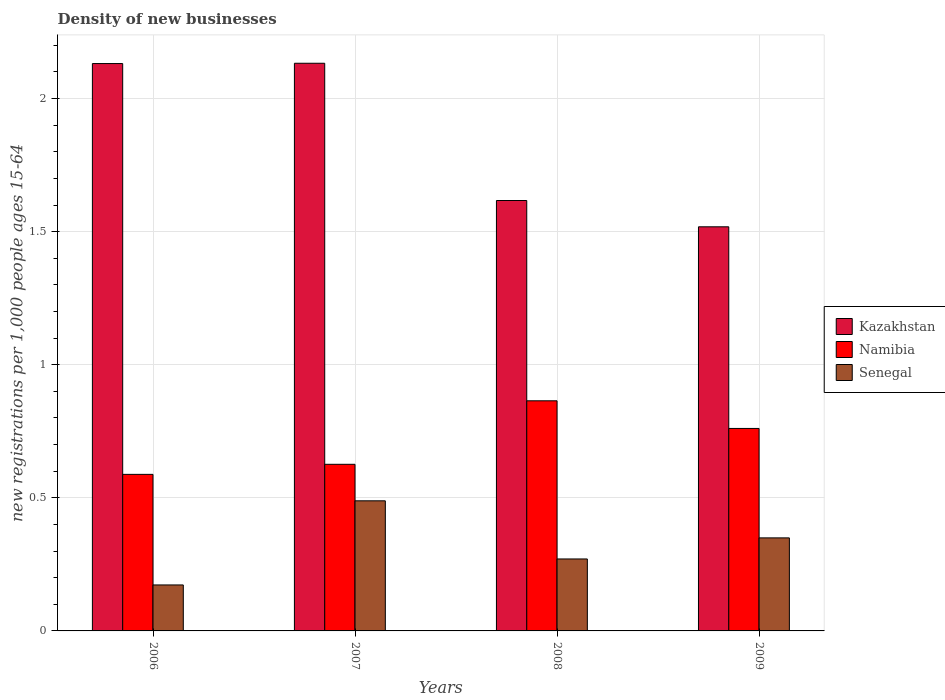How many different coloured bars are there?
Your answer should be very brief. 3. Are the number of bars per tick equal to the number of legend labels?
Your answer should be very brief. Yes. Are the number of bars on each tick of the X-axis equal?
Provide a succinct answer. Yes. How many bars are there on the 3rd tick from the left?
Keep it short and to the point. 3. How many bars are there on the 2nd tick from the right?
Make the answer very short. 3. What is the number of new registrations in Kazakhstan in 2007?
Offer a very short reply. 2.13. Across all years, what is the maximum number of new registrations in Senegal?
Keep it short and to the point. 0.49. Across all years, what is the minimum number of new registrations in Kazakhstan?
Offer a terse response. 1.52. What is the total number of new registrations in Kazakhstan in the graph?
Your response must be concise. 7.4. What is the difference between the number of new registrations in Kazakhstan in 2007 and that in 2008?
Your answer should be very brief. 0.52. What is the difference between the number of new registrations in Kazakhstan in 2007 and the number of new registrations in Senegal in 2009?
Your response must be concise. 1.78. What is the average number of new registrations in Namibia per year?
Provide a succinct answer. 0.71. In the year 2008, what is the difference between the number of new registrations in Namibia and number of new registrations in Senegal?
Your answer should be very brief. 0.59. What is the ratio of the number of new registrations in Senegal in 2007 to that in 2009?
Ensure brevity in your answer.  1.4. Is the difference between the number of new registrations in Namibia in 2008 and 2009 greater than the difference between the number of new registrations in Senegal in 2008 and 2009?
Provide a succinct answer. Yes. What is the difference between the highest and the second highest number of new registrations in Namibia?
Offer a very short reply. 0.1. What is the difference between the highest and the lowest number of new registrations in Senegal?
Provide a short and direct response. 0.32. In how many years, is the number of new registrations in Senegal greater than the average number of new registrations in Senegal taken over all years?
Your answer should be very brief. 2. Is the sum of the number of new registrations in Kazakhstan in 2008 and 2009 greater than the maximum number of new registrations in Namibia across all years?
Ensure brevity in your answer.  Yes. What does the 1st bar from the left in 2009 represents?
Ensure brevity in your answer.  Kazakhstan. What does the 3rd bar from the right in 2007 represents?
Make the answer very short. Kazakhstan. How many bars are there?
Ensure brevity in your answer.  12. Are all the bars in the graph horizontal?
Your answer should be compact. No. What is the difference between two consecutive major ticks on the Y-axis?
Make the answer very short. 0.5. Are the values on the major ticks of Y-axis written in scientific E-notation?
Ensure brevity in your answer.  No. Does the graph contain any zero values?
Ensure brevity in your answer.  No. Where does the legend appear in the graph?
Keep it short and to the point. Center right. How many legend labels are there?
Make the answer very short. 3. What is the title of the graph?
Provide a succinct answer. Density of new businesses. Does "Bosnia and Herzegovina" appear as one of the legend labels in the graph?
Make the answer very short. No. What is the label or title of the X-axis?
Keep it short and to the point. Years. What is the label or title of the Y-axis?
Keep it short and to the point. New registrations per 1,0 people ages 15-64. What is the new registrations per 1,000 people ages 15-64 in Kazakhstan in 2006?
Provide a succinct answer. 2.13. What is the new registrations per 1,000 people ages 15-64 of Namibia in 2006?
Offer a very short reply. 0.59. What is the new registrations per 1,000 people ages 15-64 of Senegal in 2006?
Make the answer very short. 0.17. What is the new registrations per 1,000 people ages 15-64 of Kazakhstan in 2007?
Keep it short and to the point. 2.13. What is the new registrations per 1,000 people ages 15-64 of Namibia in 2007?
Keep it short and to the point. 0.63. What is the new registrations per 1,000 people ages 15-64 of Senegal in 2007?
Keep it short and to the point. 0.49. What is the new registrations per 1,000 people ages 15-64 of Kazakhstan in 2008?
Provide a short and direct response. 1.62. What is the new registrations per 1,000 people ages 15-64 of Namibia in 2008?
Give a very brief answer. 0.86. What is the new registrations per 1,000 people ages 15-64 in Senegal in 2008?
Ensure brevity in your answer.  0.27. What is the new registrations per 1,000 people ages 15-64 in Kazakhstan in 2009?
Your answer should be very brief. 1.52. What is the new registrations per 1,000 people ages 15-64 of Namibia in 2009?
Your answer should be compact. 0.76. What is the new registrations per 1,000 people ages 15-64 of Senegal in 2009?
Ensure brevity in your answer.  0.35. Across all years, what is the maximum new registrations per 1,000 people ages 15-64 in Kazakhstan?
Offer a very short reply. 2.13. Across all years, what is the maximum new registrations per 1,000 people ages 15-64 in Namibia?
Give a very brief answer. 0.86. Across all years, what is the maximum new registrations per 1,000 people ages 15-64 of Senegal?
Your answer should be very brief. 0.49. Across all years, what is the minimum new registrations per 1,000 people ages 15-64 of Kazakhstan?
Your response must be concise. 1.52. Across all years, what is the minimum new registrations per 1,000 people ages 15-64 in Namibia?
Your answer should be compact. 0.59. Across all years, what is the minimum new registrations per 1,000 people ages 15-64 of Senegal?
Make the answer very short. 0.17. What is the total new registrations per 1,000 people ages 15-64 of Kazakhstan in the graph?
Your answer should be very brief. 7.4. What is the total new registrations per 1,000 people ages 15-64 of Namibia in the graph?
Give a very brief answer. 2.84. What is the total new registrations per 1,000 people ages 15-64 of Senegal in the graph?
Make the answer very short. 1.28. What is the difference between the new registrations per 1,000 people ages 15-64 in Kazakhstan in 2006 and that in 2007?
Ensure brevity in your answer.  -0. What is the difference between the new registrations per 1,000 people ages 15-64 in Namibia in 2006 and that in 2007?
Offer a terse response. -0.04. What is the difference between the new registrations per 1,000 people ages 15-64 of Senegal in 2006 and that in 2007?
Give a very brief answer. -0.32. What is the difference between the new registrations per 1,000 people ages 15-64 in Kazakhstan in 2006 and that in 2008?
Provide a succinct answer. 0.51. What is the difference between the new registrations per 1,000 people ages 15-64 of Namibia in 2006 and that in 2008?
Your response must be concise. -0.28. What is the difference between the new registrations per 1,000 people ages 15-64 of Senegal in 2006 and that in 2008?
Keep it short and to the point. -0.1. What is the difference between the new registrations per 1,000 people ages 15-64 in Kazakhstan in 2006 and that in 2009?
Ensure brevity in your answer.  0.61. What is the difference between the new registrations per 1,000 people ages 15-64 of Namibia in 2006 and that in 2009?
Your answer should be compact. -0.17. What is the difference between the new registrations per 1,000 people ages 15-64 of Senegal in 2006 and that in 2009?
Keep it short and to the point. -0.18. What is the difference between the new registrations per 1,000 people ages 15-64 of Kazakhstan in 2007 and that in 2008?
Ensure brevity in your answer.  0.52. What is the difference between the new registrations per 1,000 people ages 15-64 of Namibia in 2007 and that in 2008?
Offer a terse response. -0.24. What is the difference between the new registrations per 1,000 people ages 15-64 in Senegal in 2007 and that in 2008?
Offer a very short reply. 0.22. What is the difference between the new registrations per 1,000 people ages 15-64 in Kazakhstan in 2007 and that in 2009?
Your answer should be compact. 0.61. What is the difference between the new registrations per 1,000 people ages 15-64 in Namibia in 2007 and that in 2009?
Give a very brief answer. -0.13. What is the difference between the new registrations per 1,000 people ages 15-64 in Senegal in 2007 and that in 2009?
Give a very brief answer. 0.14. What is the difference between the new registrations per 1,000 people ages 15-64 in Kazakhstan in 2008 and that in 2009?
Make the answer very short. 0.1. What is the difference between the new registrations per 1,000 people ages 15-64 in Namibia in 2008 and that in 2009?
Provide a succinct answer. 0.1. What is the difference between the new registrations per 1,000 people ages 15-64 in Senegal in 2008 and that in 2009?
Your answer should be very brief. -0.08. What is the difference between the new registrations per 1,000 people ages 15-64 in Kazakhstan in 2006 and the new registrations per 1,000 people ages 15-64 in Namibia in 2007?
Provide a succinct answer. 1.51. What is the difference between the new registrations per 1,000 people ages 15-64 in Kazakhstan in 2006 and the new registrations per 1,000 people ages 15-64 in Senegal in 2007?
Provide a succinct answer. 1.64. What is the difference between the new registrations per 1,000 people ages 15-64 in Namibia in 2006 and the new registrations per 1,000 people ages 15-64 in Senegal in 2007?
Give a very brief answer. 0.1. What is the difference between the new registrations per 1,000 people ages 15-64 in Kazakhstan in 2006 and the new registrations per 1,000 people ages 15-64 in Namibia in 2008?
Keep it short and to the point. 1.27. What is the difference between the new registrations per 1,000 people ages 15-64 in Kazakhstan in 2006 and the new registrations per 1,000 people ages 15-64 in Senegal in 2008?
Your answer should be very brief. 1.86. What is the difference between the new registrations per 1,000 people ages 15-64 of Namibia in 2006 and the new registrations per 1,000 people ages 15-64 of Senegal in 2008?
Give a very brief answer. 0.32. What is the difference between the new registrations per 1,000 people ages 15-64 in Kazakhstan in 2006 and the new registrations per 1,000 people ages 15-64 in Namibia in 2009?
Your answer should be compact. 1.37. What is the difference between the new registrations per 1,000 people ages 15-64 of Kazakhstan in 2006 and the new registrations per 1,000 people ages 15-64 of Senegal in 2009?
Provide a succinct answer. 1.78. What is the difference between the new registrations per 1,000 people ages 15-64 in Namibia in 2006 and the new registrations per 1,000 people ages 15-64 in Senegal in 2009?
Your answer should be very brief. 0.24. What is the difference between the new registrations per 1,000 people ages 15-64 of Kazakhstan in 2007 and the new registrations per 1,000 people ages 15-64 of Namibia in 2008?
Provide a succinct answer. 1.27. What is the difference between the new registrations per 1,000 people ages 15-64 of Kazakhstan in 2007 and the new registrations per 1,000 people ages 15-64 of Senegal in 2008?
Offer a terse response. 1.86. What is the difference between the new registrations per 1,000 people ages 15-64 in Namibia in 2007 and the new registrations per 1,000 people ages 15-64 in Senegal in 2008?
Provide a succinct answer. 0.36. What is the difference between the new registrations per 1,000 people ages 15-64 of Kazakhstan in 2007 and the new registrations per 1,000 people ages 15-64 of Namibia in 2009?
Provide a succinct answer. 1.37. What is the difference between the new registrations per 1,000 people ages 15-64 of Kazakhstan in 2007 and the new registrations per 1,000 people ages 15-64 of Senegal in 2009?
Give a very brief answer. 1.78. What is the difference between the new registrations per 1,000 people ages 15-64 of Namibia in 2007 and the new registrations per 1,000 people ages 15-64 of Senegal in 2009?
Your answer should be very brief. 0.28. What is the difference between the new registrations per 1,000 people ages 15-64 in Kazakhstan in 2008 and the new registrations per 1,000 people ages 15-64 in Namibia in 2009?
Keep it short and to the point. 0.86. What is the difference between the new registrations per 1,000 people ages 15-64 in Kazakhstan in 2008 and the new registrations per 1,000 people ages 15-64 in Senegal in 2009?
Your answer should be compact. 1.27. What is the difference between the new registrations per 1,000 people ages 15-64 of Namibia in 2008 and the new registrations per 1,000 people ages 15-64 of Senegal in 2009?
Make the answer very short. 0.52. What is the average new registrations per 1,000 people ages 15-64 in Kazakhstan per year?
Ensure brevity in your answer.  1.85. What is the average new registrations per 1,000 people ages 15-64 in Namibia per year?
Your response must be concise. 0.71. What is the average new registrations per 1,000 people ages 15-64 of Senegal per year?
Make the answer very short. 0.32. In the year 2006, what is the difference between the new registrations per 1,000 people ages 15-64 of Kazakhstan and new registrations per 1,000 people ages 15-64 of Namibia?
Keep it short and to the point. 1.54. In the year 2006, what is the difference between the new registrations per 1,000 people ages 15-64 of Kazakhstan and new registrations per 1,000 people ages 15-64 of Senegal?
Ensure brevity in your answer.  1.96. In the year 2006, what is the difference between the new registrations per 1,000 people ages 15-64 of Namibia and new registrations per 1,000 people ages 15-64 of Senegal?
Ensure brevity in your answer.  0.42. In the year 2007, what is the difference between the new registrations per 1,000 people ages 15-64 of Kazakhstan and new registrations per 1,000 people ages 15-64 of Namibia?
Offer a terse response. 1.51. In the year 2007, what is the difference between the new registrations per 1,000 people ages 15-64 in Kazakhstan and new registrations per 1,000 people ages 15-64 in Senegal?
Offer a very short reply. 1.64. In the year 2007, what is the difference between the new registrations per 1,000 people ages 15-64 of Namibia and new registrations per 1,000 people ages 15-64 of Senegal?
Your response must be concise. 0.14. In the year 2008, what is the difference between the new registrations per 1,000 people ages 15-64 in Kazakhstan and new registrations per 1,000 people ages 15-64 in Namibia?
Provide a succinct answer. 0.75. In the year 2008, what is the difference between the new registrations per 1,000 people ages 15-64 in Kazakhstan and new registrations per 1,000 people ages 15-64 in Senegal?
Provide a succinct answer. 1.35. In the year 2008, what is the difference between the new registrations per 1,000 people ages 15-64 of Namibia and new registrations per 1,000 people ages 15-64 of Senegal?
Your answer should be compact. 0.59. In the year 2009, what is the difference between the new registrations per 1,000 people ages 15-64 of Kazakhstan and new registrations per 1,000 people ages 15-64 of Namibia?
Keep it short and to the point. 0.76. In the year 2009, what is the difference between the new registrations per 1,000 people ages 15-64 in Kazakhstan and new registrations per 1,000 people ages 15-64 in Senegal?
Offer a terse response. 1.17. In the year 2009, what is the difference between the new registrations per 1,000 people ages 15-64 in Namibia and new registrations per 1,000 people ages 15-64 in Senegal?
Ensure brevity in your answer.  0.41. What is the ratio of the new registrations per 1,000 people ages 15-64 of Kazakhstan in 2006 to that in 2007?
Give a very brief answer. 1. What is the ratio of the new registrations per 1,000 people ages 15-64 in Namibia in 2006 to that in 2007?
Provide a succinct answer. 0.94. What is the ratio of the new registrations per 1,000 people ages 15-64 of Senegal in 2006 to that in 2007?
Your answer should be compact. 0.35. What is the ratio of the new registrations per 1,000 people ages 15-64 of Kazakhstan in 2006 to that in 2008?
Ensure brevity in your answer.  1.32. What is the ratio of the new registrations per 1,000 people ages 15-64 in Namibia in 2006 to that in 2008?
Keep it short and to the point. 0.68. What is the ratio of the new registrations per 1,000 people ages 15-64 of Senegal in 2006 to that in 2008?
Your answer should be very brief. 0.64. What is the ratio of the new registrations per 1,000 people ages 15-64 of Kazakhstan in 2006 to that in 2009?
Provide a succinct answer. 1.4. What is the ratio of the new registrations per 1,000 people ages 15-64 in Namibia in 2006 to that in 2009?
Your answer should be very brief. 0.77. What is the ratio of the new registrations per 1,000 people ages 15-64 in Senegal in 2006 to that in 2009?
Make the answer very short. 0.49. What is the ratio of the new registrations per 1,000 people ages 15-64 in Kazakhstan in 2007 to that in 2008?
Your answer should be very brief. 1.32. What is the ratio of the new registrations per 1,000 people ages 15-64 of Namibia in 2007 to that in 2008?
Offer a terse response. 0.72. What is the ratio of the new registrations per 1,000 people ages 15-64 in Senegal in 2007 to that in 2008?
Offer a terse response. 1.81. What is the ratio of the new registrations per 1,000 people ages 15-64 in Kazakhstan in 2007 to that in 2009?
Offer a very short reply. 1.4. What is the ratio of the new registrations per 1,000 people ages 15-64 of Namibia in 2007 to that in 2009?
Your answer should be compact. 0.82. What is the ratio of the new registrations per 1,000 people ages 15-64 in Senegal in 2007 to that in 2009?
Make the answer very short. 1.4. What is the ratio of the new registrations per 1,000 people ages 15-64 of Kazakhstan in 2008 to that in 2009?
Ensure brevity in your answer.  1.07. What is the ratio of the new registrations per 1,000 people ages 15-64 of Namibia in 2008 to that in 2009?
Ensure brevity in your answer.  1.14. What is the ratio of the new registrations per 1,000 people ages 15-64 in Senegal in 2008 to that in 2009?
Offer a very short reply. 0.77. What is the difference between the highest and the second highest new registrations per 1,000 people ages 15-64 of Kazakhstan?
Your response must be concise. 0. What is the difference between the highest and the second highest new registrations per 1,000 people ages 15-64 in Namibia?
Offer a terse response. 0.1. What is the difference between the highest and the second highest new registrations per 1,000 people ages 15-64 of Senegal?
Provide a short and direct response. 0.14. What is the difference between the highest and the lowest new registrations per 1,000 people ages 15-64 of Kazakhstan?
Give a very brief answer. 0.61. What is the difference between the highest and the lowest new registrations per 1,000 people ages 15-64 in Namibia?
Offer a terse response. 0.28. What is the difference between the highest and the lowest new registrations per 1,000 people ages 15-64 in Senegal?
Make the answer very short. 0.32. 